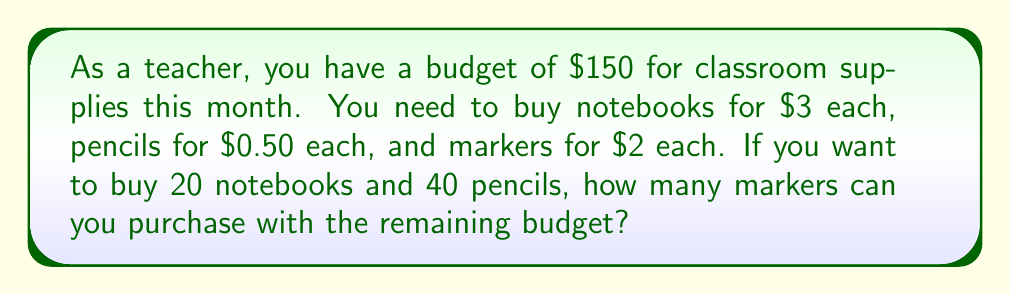Could you help me with this problem? Let's solve this problem step by step:

1. Calculate the cost of notebooks:
   $20 \times $3 = $60$

2. Calculate the cost of pencils:
   $40 \times $0.50 = $20$

3. Calculate the total spent on notebooks and pencils:
   $60 + $20 = $80$

4. Calculate the remaining budget:
   $150 - $80 = $70$

5. Calculate how many markers can be purchased:
   Let $x$ be the number of markers.
   Each marker costs $2, so the equation is:
   $2x = 70$

6. Solve for $x$:
   $x = 70 \div 2 = 35$

Therefore, you can purchase 35 markers with the remaining budget.
Answer: 35 markers 